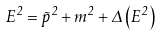<formula> <loc_0><loc_0><loc_500><loc_500>E ^ { 2 } = \vec { p } ^ { 2 } + m ^ { 2 } + \Delta \left ( { E ^ { 2 } } \right )</formula> 